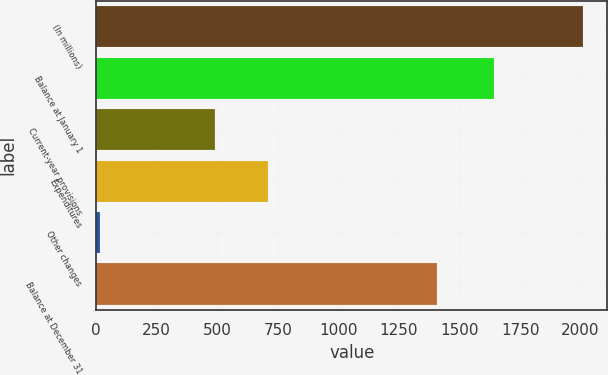Convert chart to OTSL. <chart><loc_0><loc_0><loc_500><loc_500><bar_chart><fcel>(In millions)<fcel>Balance at January 1<fcel>Current-year provisions<fcel>Expenditures<fcel>Other changes<fcel>Balance at December 31<nl><fcel>2010<fcel>1641<fcel>491<fcel>710<fcel>17<fcel>1405<nl></chart> 